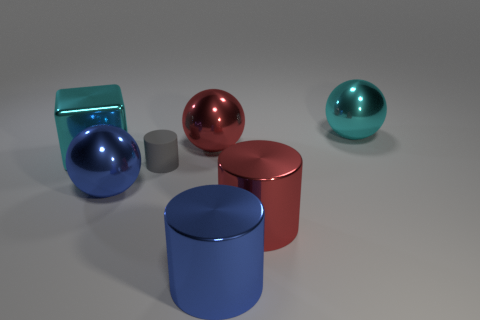Add 3 shiny blocks. How many objects exist? 10 Subtract all balls. How many objects are left? 4 Subtract 0 yellow spheres. How many objects are left? 7 Subtract all large blocks. Subtract all big red metallic objects. How many objects are left? 4 Add 2 blue metal cylinders. How many blue metal cylinders are left? 3 Add 2 big cubes. How many big cubes exist? 3 